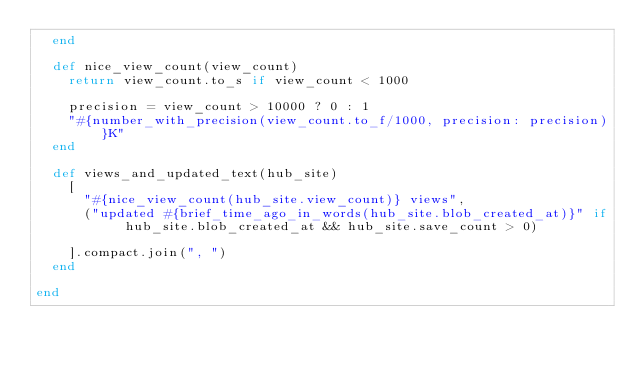<code> <loc_0><loc_0><loc_500><loc_500><_Ruby_>  end

  def nice_view_count(view_count)
    return view_count.to_s if view_count < 1000

    precision = view_count > 10000 ? 0 : 1
    "#{number_with_precision(view_count.to_f/1000, precision: precision)}K"
  end

  def views_and_updated_text(hub_site)
    [
      "#{nice_view_count(hub_site.view_count)} views",
      ("updated #{brief_time_ago_in_words(hub_site.blob_created_at)}" if hub_site.blob_created_at && hub_site.save_count > 0)

    ].compact.join(", ")
  end

end
</code> 